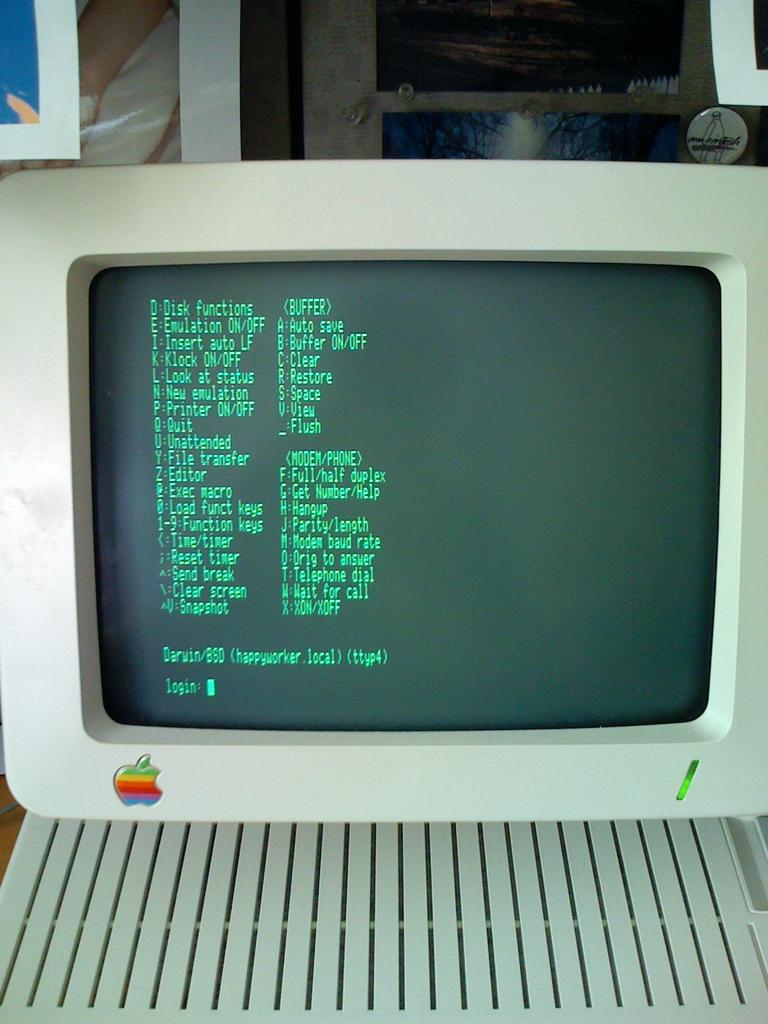What electronic device is visible in the image? There is a monitor in the image. What can be seen in the background of the image? There are frames in the background of the image. What type of earth can be seen in the image? There is no earth visible in the image; it features a monitor and frames in the background. What kind of beam is supporting the monitor in the image? There is no beam visible in the image; it only shows a monitor and frames in the background. 